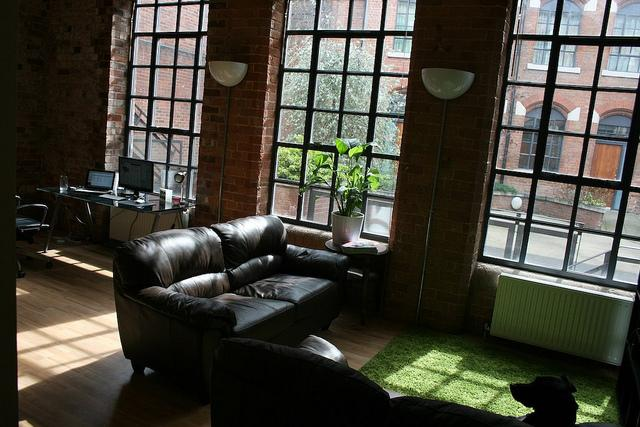Which two species often share this space? dogs humans 